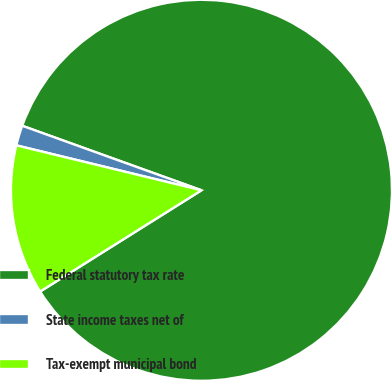Convert chart to OTSL. <chart><loc_0><loc_0><loc_500><loc_500><pie_chart><fcel>Federal statutory tax rate<fcel>State income taxes net of<fcel>Tax-exempt municipal bond<nl><fcel>85.57%<fcel>1.71%<fcel>12.71%<nl></chart> 